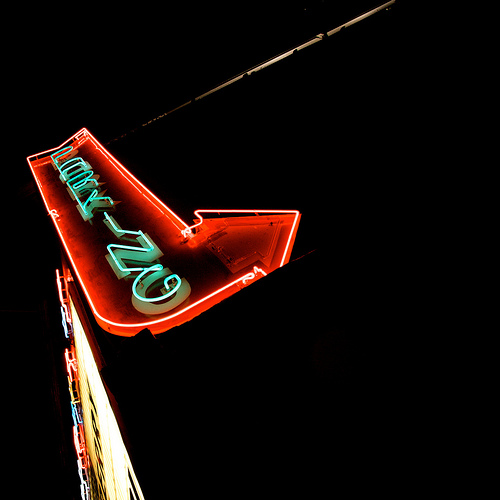<image>
Can you confirm if the wall is next to the wall? No. The wall is not positioned next to the wall. They are located in different areas of the scene. 